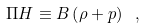<formula> <loc_0><loc_0><loc_500><loc_500>\Pi H \equiv B \left ( \rho + p \right ) \ ,</formula> 